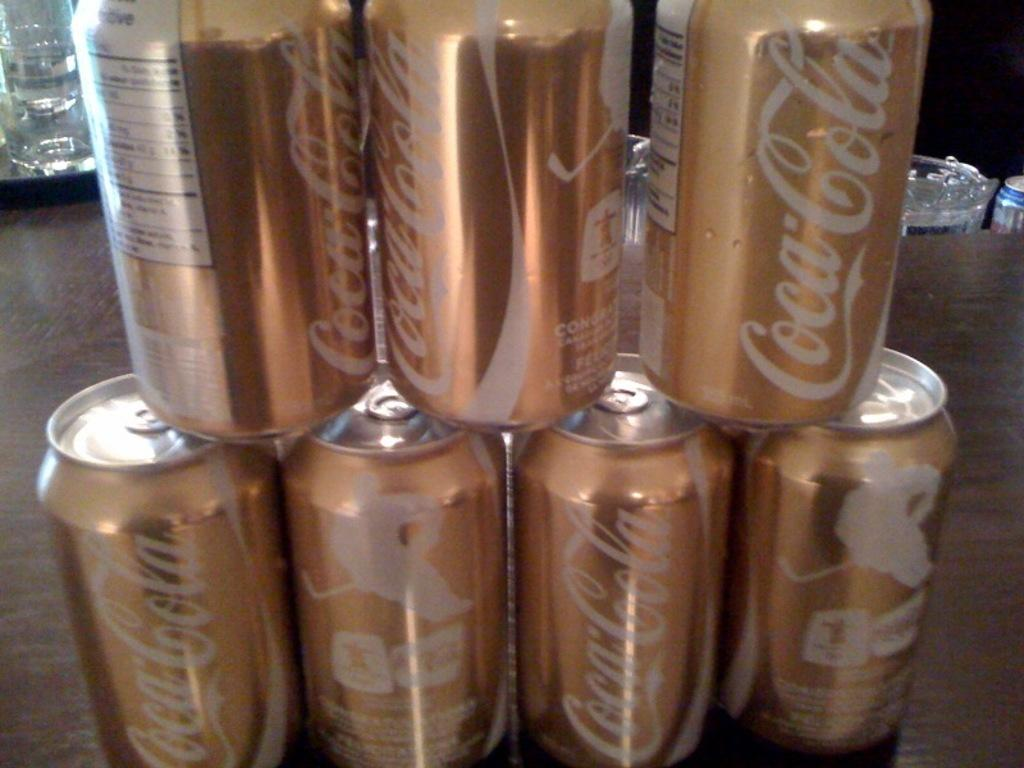<image>
Create a compact narrative representing the image presented. Special edition Coca-Cola gold shiny cans stacked on top of each other. 